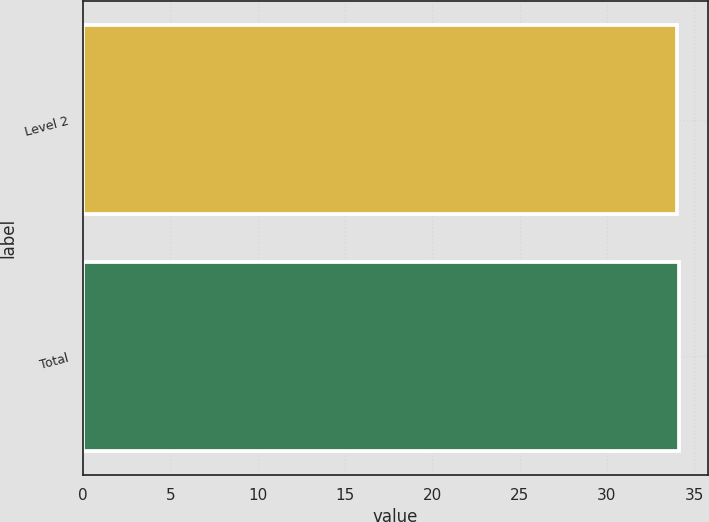Convert chart to OTSL. <chart><loc_0><loc_0><loc_500><loc_500><bar_chart><fcel>Level 2<fcel>Total<nl><fcel>34<fcel>34.1<nl></chart> 